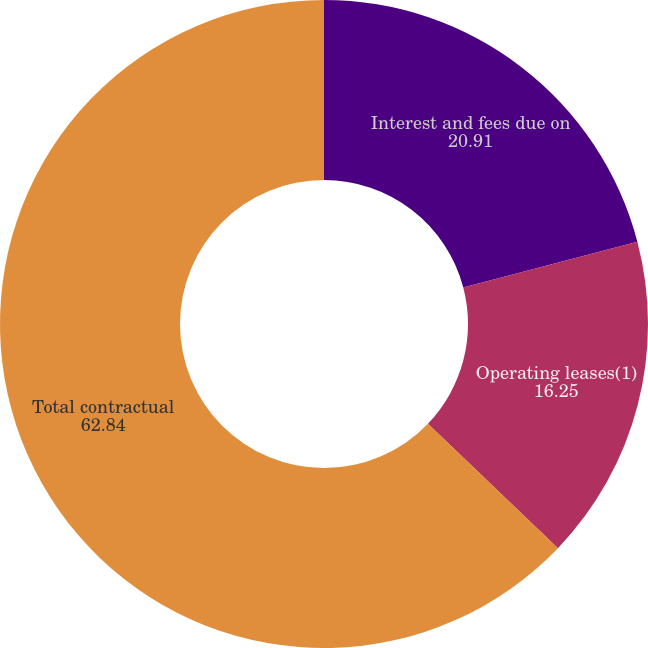Convert chart to OTSL. <chart><loc_0><loc_0><loc_500><loc_500><pie_chart><fcel>Interest and fees due on<fcel>Operating leases(1)<fcel>Total contractual<nl><fcel>20.91%<fcel>16.25%<fcel>62.84%<nl></chart> 